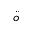Convert formula to latex. <formula><loc_0><loc_0><loc_500><loc_500>\ddot { o }</formula> 